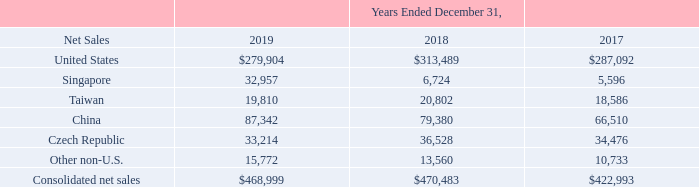NOTES TO CONSOLIDATED FINANCIAL STATEMENTS (in thousands, except for share and per share data)
NOTE 20 — Geographic Data
Financial information relating to our operations by geographic area were as follows:
Sales are attributed to countries based upon the origin of the sale.
Which years does the table provide information relating to the company's operations by geographic area? 2019, 2018, 2017. What was the net sales from Other non-U.S. countries in 2019?
Answer scale should be: thousand. 15,772. What were the consolidated net sales in 2017?
Answer scale should be: thousand. 422,993. How many years did the net sales from Singapore exceed $10,000 thousand? 2019
Answer: 1. What was the change in the net sales from United States between 2017 and 2018?
Answer scale should be: thousand. 313,489-287,092
Answer: 26397. What was the percentage change in consolidated net sales between 2018 and 2019?
Answer scale should be: percent. (468,999-470,483)/470,483
Answer: -0.32. 